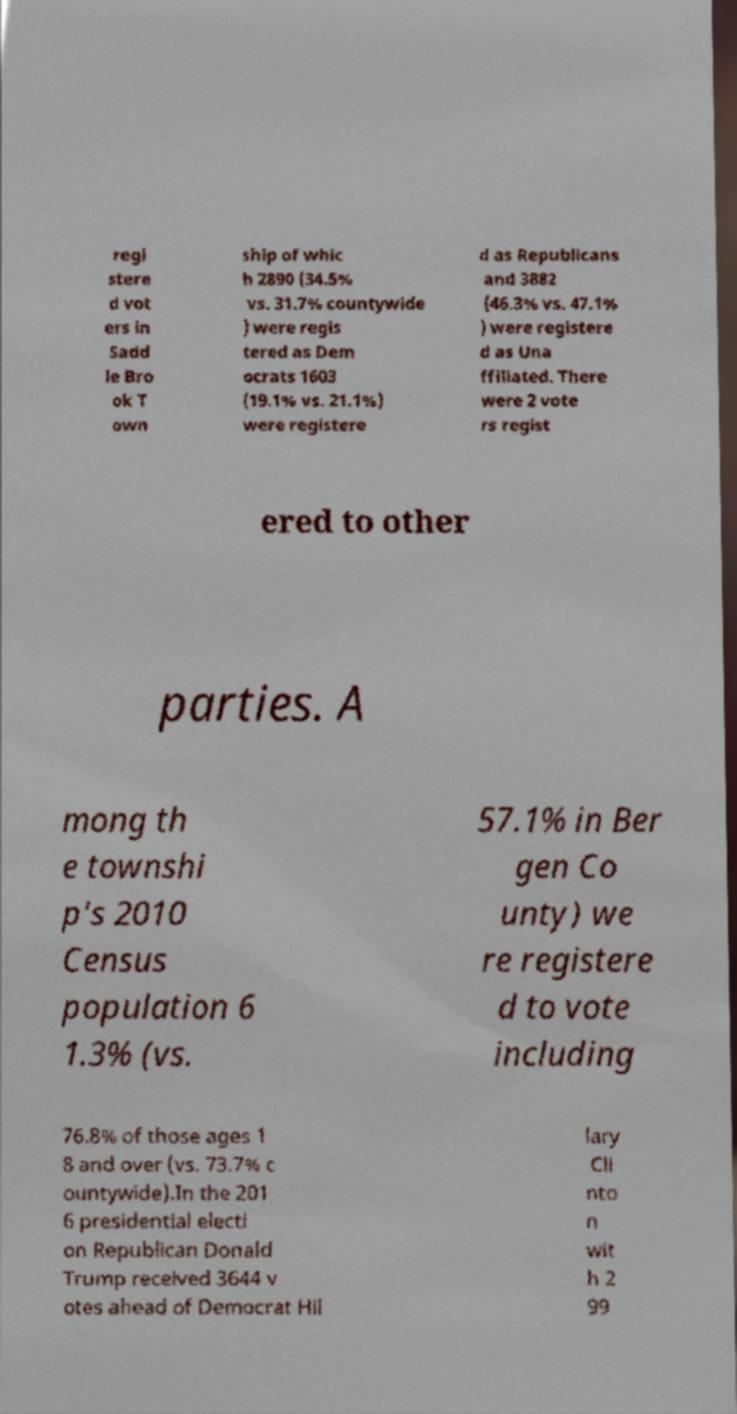For documentation purposes, I need the text within this image transcribed. Could you provide that? regi stere d vot ers in Sadd le Bro ok T own ship of whic h 2890 (34.5% vs. 31.7% countywide ) were regis tered as Dem ocrats 1603 (19.1% vs. 21.1%) were registere d as Republicans and 3882 (46.3% vs. 47.1% ) were registere d as Una ffiliated. There were 2 vote rs regist ered to other parties. A mong th e townshi p's 2010 Census population 6 1.3% (vs. 57.1% in Ber gen Co unty) we re registere d to vote including 76.8% of those ages 1 8 and over (vs. 73.7% c ountywide).In the 201 6 presidential electi on Republican Donald Trump received 3644 v otes ahead of Democrat Hil lary Cli nto n wit h 2 99 